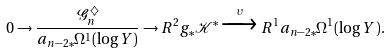<formula> <loc_0><loc_0><loc_500><loc_500>0 \to \frac { \mathcal { G } _ { n } ^ { \diamondsuit } } { a _ { n - 2 * } \Omega ^ { 1 } ( \log Y ) } \to R ^ { 2 } g _ { * } \mathcal { K } ^ { * } \xrightarrow { \upsilon } R ^ { 1 } a _ { n - 2 * } \Omega ^ { 1 } ( \log Y ) .</formula> 